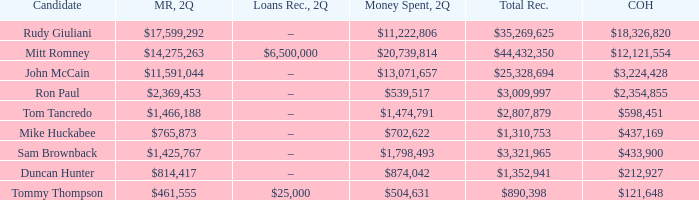Name the loans received for 2Q having total receipts of $25,328,694 –. 